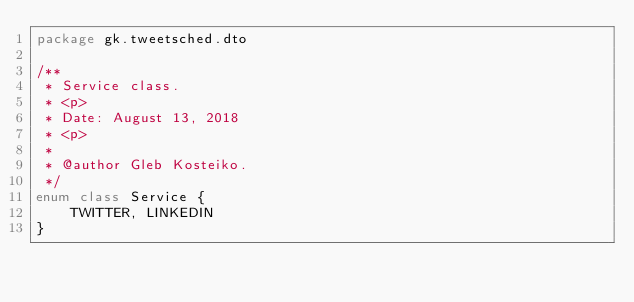<code> <loc_0><loc_0><loc_500><loc_500><_Kotlin_>package gk.tweetsched.dto

/**
 * Service class.
 * <p>
 * Date: August 13, 2018
 * <p>
 *
 * @author Gleb Kosteiko.
 */
enum class Service {
    TWITTER, LINKEDIN
}
</code> 